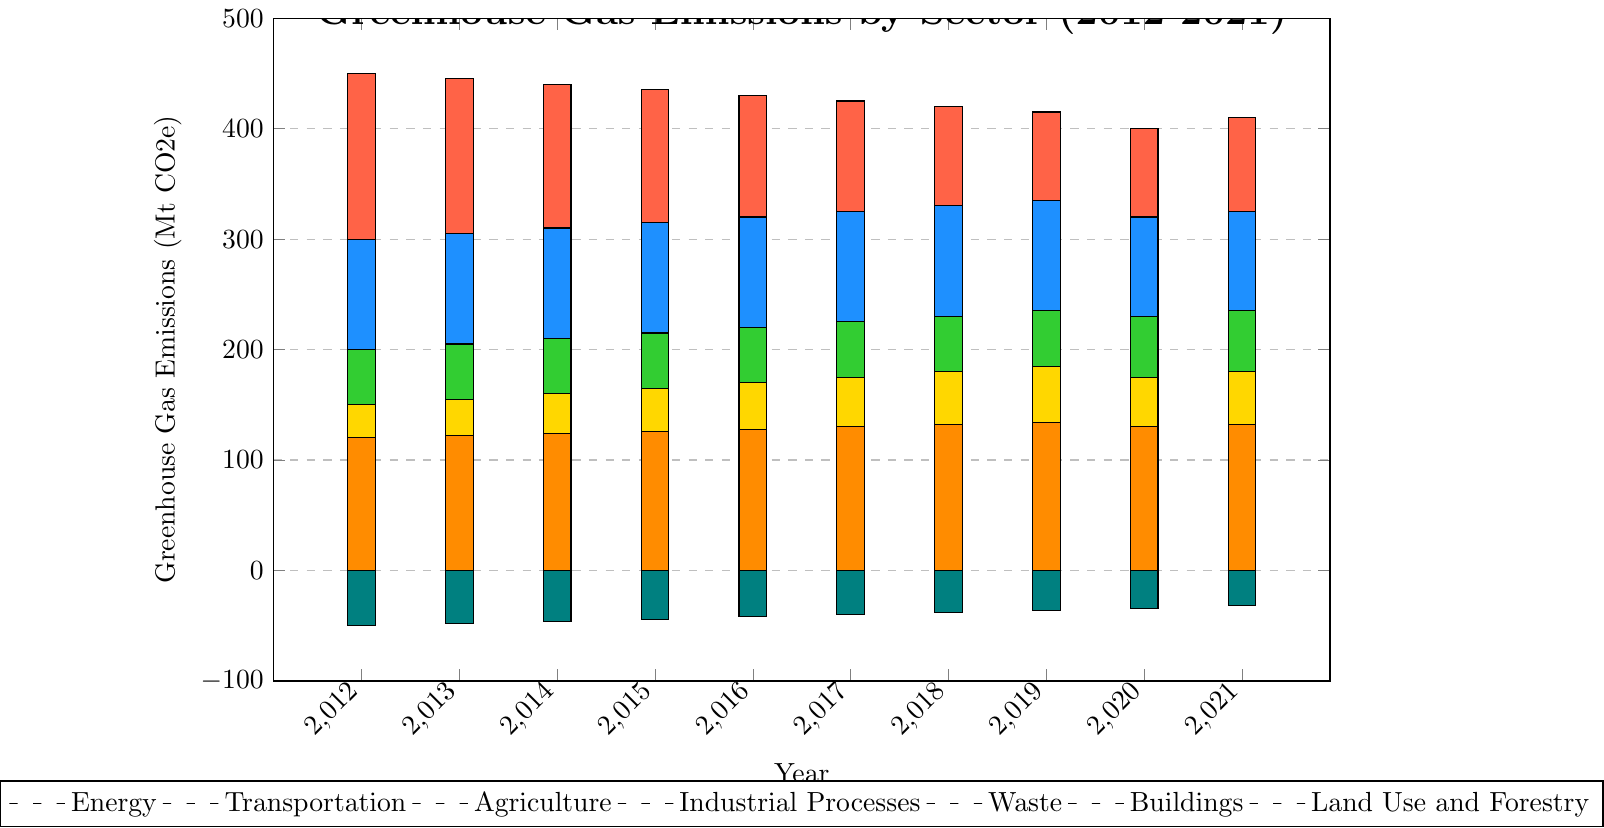What is the total greenhouse gas emissions in 2021 including all sectors? Sum the values of all sectors for the year 2021: Energy (410) + Transportation (325) + Agriculture (235) + Industrial Processes (180) + Waste (82) + Buildings (132) + Land Use and Forestry (-32). Total = 410 + 325 + 235 + 180 + 82 + 132 - 32 = 1332
Answer: 1332 Which sector had the highest greenhouse gas emissions in 2021? Look for the tallest bar in the figure for the year 2021. The Energy sector's bar (410) is the tallest among all the sectors.
Answer: Energy How did greenhouse gas emissions in the Transportation sector change from 2012 to 2021? Subtract the 2012 value (300) from the 2021 value (325) to find the change in emissions. 325 - 300 = 25, so there was an increase of 25 Mt CO2e.
Answer: Increased by 25 Mt CO2e In which year did the Waste sector have the lowest emissions, and what was the value? Observe the shortest bar in the Waste sector. The year 2021 has the lowest emissions at 82 Mt CO2e.
Answer: 2021, 82 Mt CO2e By how much did emissions in the Energy sector decrease from 2012 to 2020? Subtract the 2020 value (400) from the 2012 value (450) to find the decrease. 450 - 400 = 50 Mt CO2e.
Answer: Decreased by 50 Mt CO2e Compare the emissions of the Agriculture and Industrial Processes sectors in 2018. Which one was higher and by how much? Look at the heights of the bars for Agriculture (230) and Industrial Processes (180) in 2018. Agriculture is higher. Subtract the Industrial Processes value from Agriculture to find the difference. 230 - 180 = 50 Mt CO2e.
Answer: Agriculture by 50 Mt CO2e What is the average greenhouse gas emissions for the Buildings sector over the decade? Sum the annual emissions from 2012 to 2021 and divide by the number of years: (120 + 122 + 124 + 126 + 128 + 130 + 132 + 134 + 130 + 132) / 10 = 1278 / 10 = 127.8 Mt CO2e
Answer: 127.8 Mt CO2e Did the Land Use and Forestry sector's emissions become less negative over this period? Check the emissions trend for Land Use and Forestry from 2012 (-50) to 2021 (-32). Since the 2021 value is less negative, the emissions did become less negative.
Answer: Yes What is the total change in emissions for the Waste sector from 2012 to 2021? Subtract the 2021 value (82) from the 2012 value (100) to find the total change. 100 - 82 = 18 Mt CO2e.
Answer: Decreased by 18 Mt CO2e Which sector shows the most consistent increase in emissions over the decade? Examine the trend of all sectors. Transportation and Agriculture both show consistent increases, but Agriculture has a steady, monotonic rise from 200 to 235 Mt CO2e without a dip.
Answer: Agriculture 